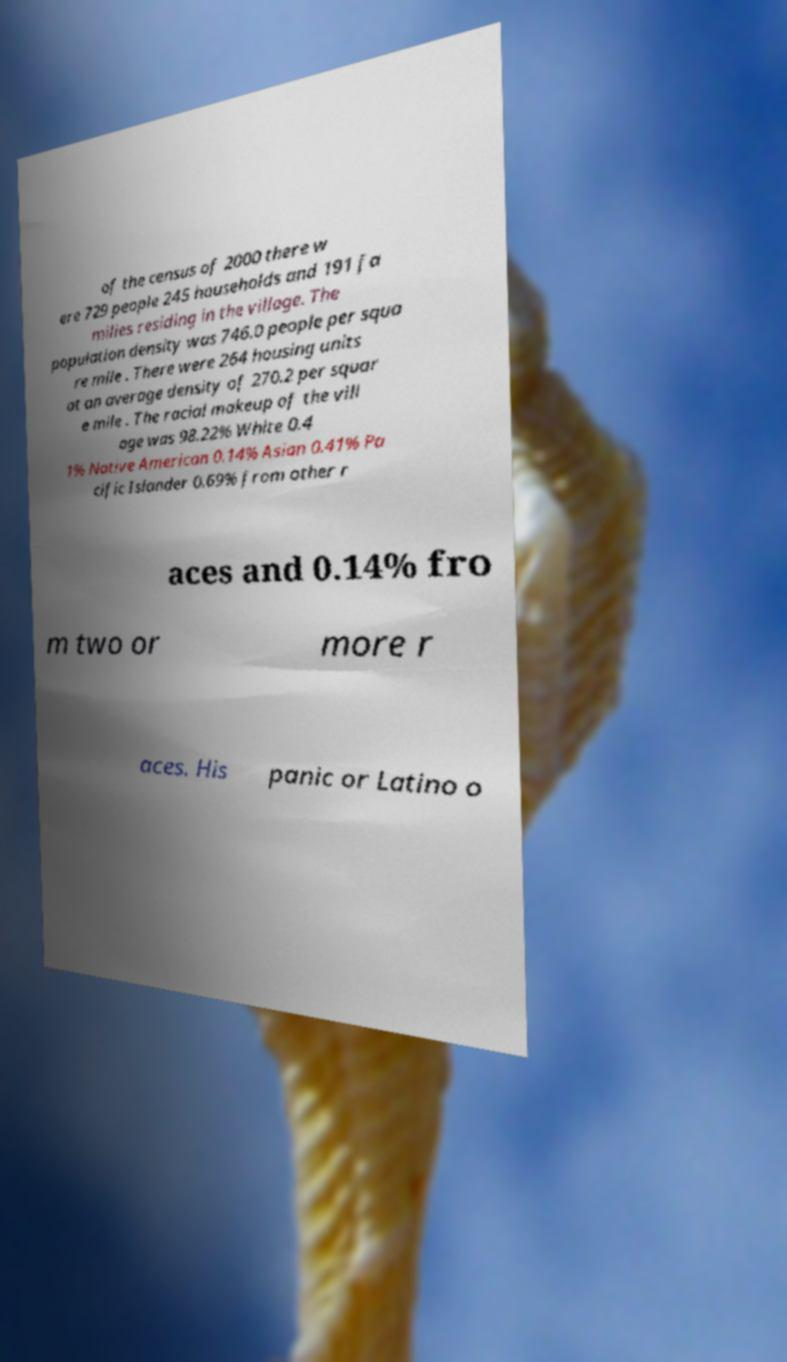Can you accurately transcribe the text from the provided image for me? of the census of 2000 there w ere 729 people 245 households and 191 fa milies residing in the village. The population density was 746.0 people per squa re mile . There were 264 housing units at an average density of 270.2 per squar e mile . The racial makeup of the vill age was 98.22% White 0.4 1% Native American 0.14% Asian 0.41% Pa cific Islander 0.69% from other r aces and 0.14% fro m two or more r aces. His panic or Latino o 